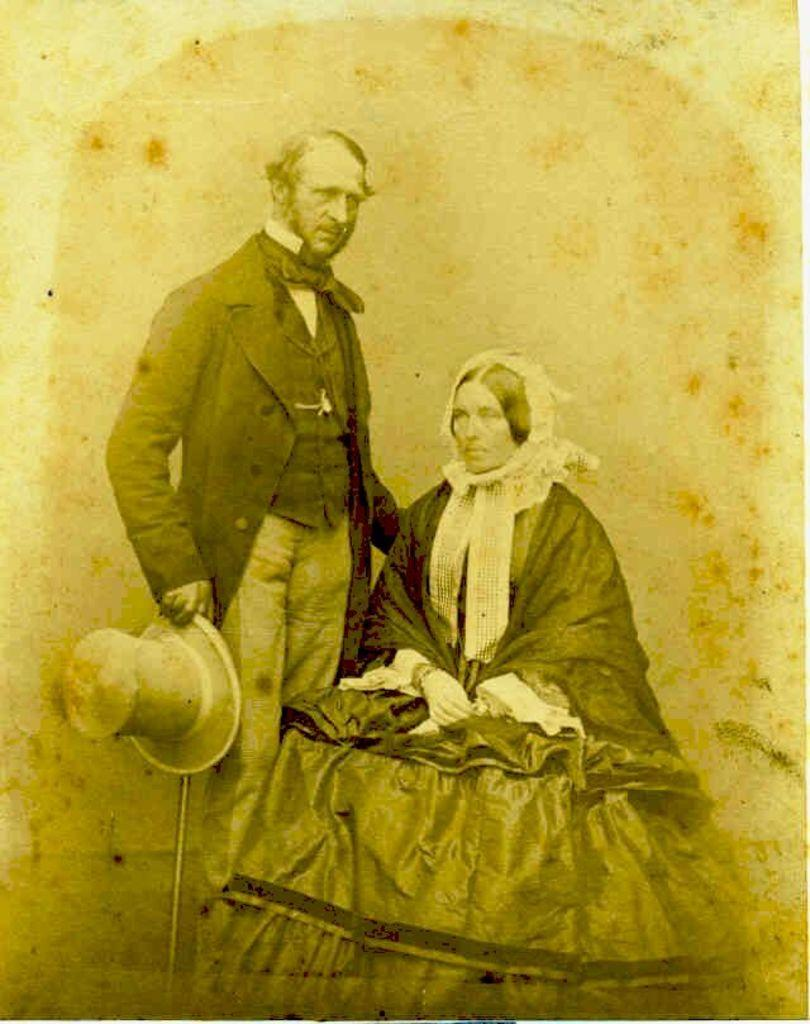What is depicted in the image? There is a photograph of a man and a woman in the image. What is the woman doing in the image? The woman is sitting. What is the woman wearing in the image? The woman is wearing a dress. What is the man holding in the image? The man is holding a cap. Can you describe the appearance of the image? The image appears to be old. Can you see a boat in the image? There is no boat present in the image. Is there a monkey sitting next to the woman in the image? There is no monkey present in the image. 